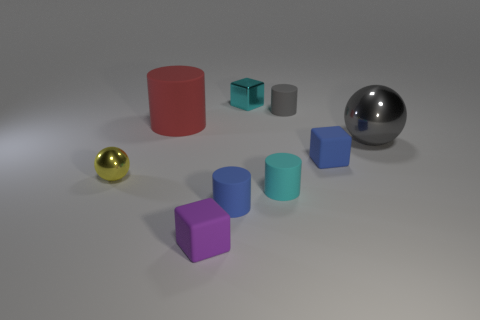Subtract all matte cubes. How many cubes are left? 1 Add 1 small purple objects. How many objects exist? 10 Subtract all blue cylinders. How many cylinders are left? 3 Subtract 1 spheres. How many spheres are left? 1 Subtract all cylinders. How many objects are left? 5 Add 2 large red cylinders. How many large red cylinders are left? 3 Add 3 yellow metallic objects. How many yellow metallic objects exist? 4 Subtract 0 green blocks. How many objects are left? 9 Subtract all purple spheres. Subtract all gray cylinders. How many spheres are left? 2 Subtract all small blue objects. Subtract all red metallic cylinders. How many objects are left? 7 